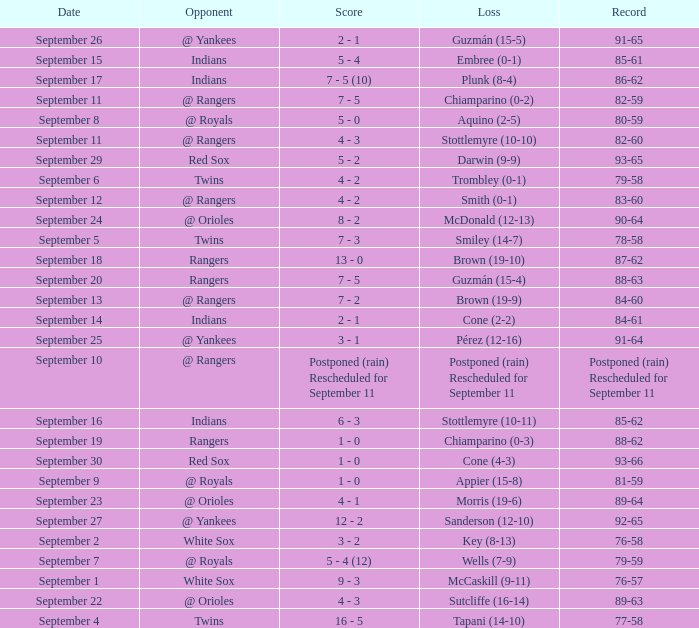What opponent has a record of 86-62? Indians. 